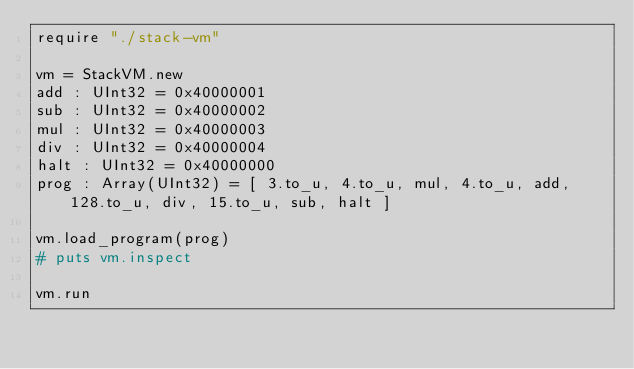<code> <loc_0><loc_0><loc_500><loc_500><_Crystal_>require "./stack-vm"

vm = StackVM.new
add : UInt32 = 0x40000001
sub : UInt32 = 0x40000002
mul : UInt32 = 0x40000003
div : UInt32 = 0x40000004
halt : UInt32 = 0x40000000
prog : Array(UInt32) = [ 3.to_u, 4.to_u, mul, 4.to_u, add, 128.to_u, div, 15.to_u, sub, halt ]

vm.load_program(prog)
# puts vm.inspect

vm.run
</code> 